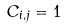<formula> <loc_0><loc_0><loc_500><loc_500>C _ { i , j } = 1</formula> 